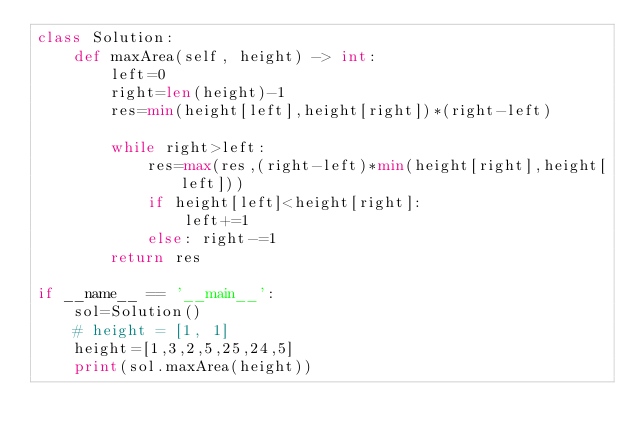Convert code to text. <code><loc_0><loc_0><loc_500><loc_500><_Python_>class Solution:
    def maxArea(self, height) -> int:
        left=0
        right=len(height)-1
        res=min(height[left],height[right])*(right-left)

        while right>left:
            res=max(res,(right-left)*min(height[right],height[left]))
            if height[left]<height[right]:
                left+=1
            else: right-=1
        return res

if __name__ == '__main__':
    sol=Solution()
    # height = [1, 1]
    height=[1,3,2,5,25,24,5]
    print(sol.maxArea(height))
</code> 